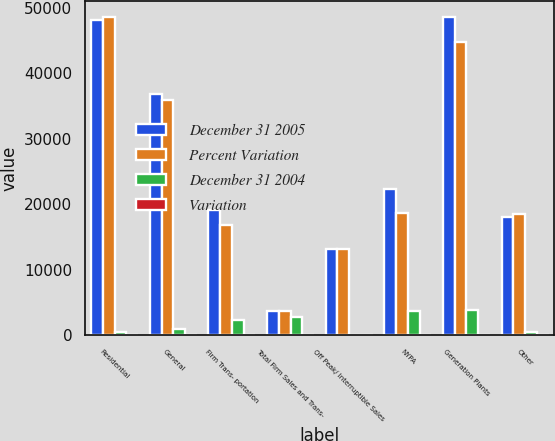Convert chart to OTSL. <chart><loc_0><loc_0><loc_500><loc_500><stacked_bar_chart><ecel><fcel>Residential<fcel>General<fcel>Firm Trans- portation<fcel>Total Firm Sales and Trans-<fcel>Off Peak/ Interruptible Sales<fcel>NYPA<fcel>Generation Plants<fcel>Other<nl><fcel>December 31 2005<fcel>48175<fcel>36800<fcel>19088<fcel>3737<fcel>13128<fcel>22305<fcel>48564<fcel>18103<nl><fcel>Percent Variation<fcel>48569<fcel>35887<fcel>16795<fcel>3737<fcel>13187<fcel>18623<fcel>44772<fcel>18534<nl><fcel>December 31 2004<fcel>394<fcel>913<fcel>2293<fcel>2812<fcel>59<fcel>3682<fcel>3792<fcel>431<nl><fcel>Variation<fcel>0.8<fcel>2.5<fcel>13.7<fcel>2.8<fcel>0.4<fcel>19.8<fcel>8.5<fcel>2.3<nl></chart> 